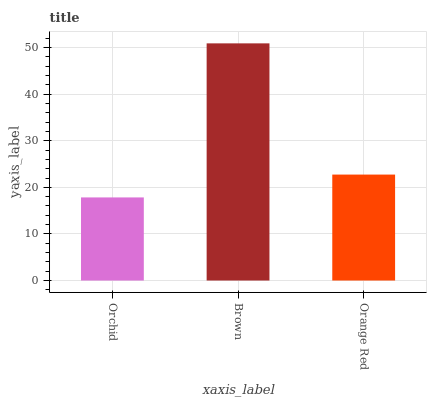Is Orchid the minimum?
Answer yes or no. Yes. Is Brown the maximum?
Answer yes or no. Yes. Is Orange Red the minimum?
Answer yes or no. No. Is Orange Red the maximum?
Answer yes or no. No. Is Brown greater than Orange Red?
Answer yes or no. Yes. Is Orange Red less than Brown?
Answer yes or no. Yes. Is Orange Red greater than Brown?
Answer yes or no. No. Is Brown less than Orange Red?
Answer yes or no. No. Is Orange Red the high median?
Answer yes or no. Yes. Is Orange Red the low median?
Answer yes or no. Yes. Is Brown the high median?
Answer yes or no. No. Is Brown the low median?
Answer yes or no. No. 